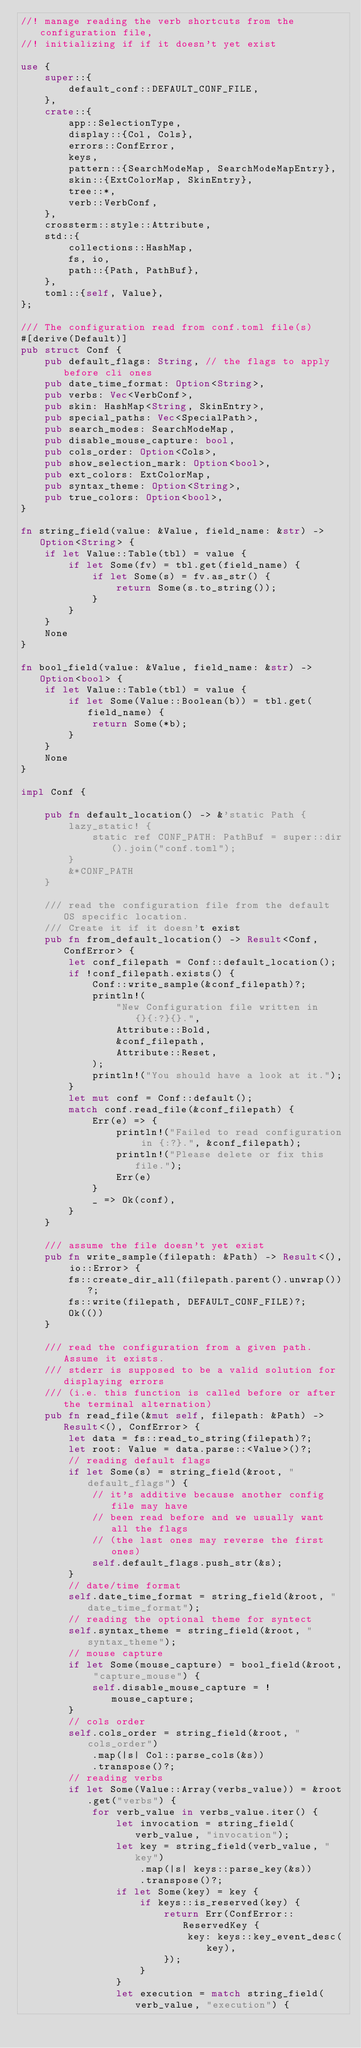Convert code to text. <code><loc_0><loc_0><loc_500><loc_500><_Rust_>//! manage reading the verb shortcuts from the configuration file,
//! initializing if if it doesn't yet exist

use {
    super::{
        default_conf::DEFAULT_CONF_FILE,
    },
    crate::{
        app::SelectionType,
        display::{Col, Cols},
        errors::ConfError,
        keys,
        pattern::{SearchModeMap, SearchModeMapEntry},
        skin::{ExtColorMap, SkinEntry},
        tree::*,
        verb::VerbConf,
    },
    crossterm::style::Attribute,
    std::{
        collections::HashMap,
        fs, io,
        path::{Path, PathBuf},
    },
    toml::{self, Value},
};

/// The configuration read from conf.toml file(s)
#[derive(Default)]
pub struct Conf {
    pub default_flags: String, // the flags to apply before cli ones
    pub date_time_format: Option<String>,
    pub verbs: Vec<VerbConf>,
    pub skin: HashMap<String, SkinEntry>,
    pub special_paths: Vec<SpecialPath>,
    pub search_modes: SearchModeMap,
    pub disable_mouse_capture: bool,
    pub cols_order: Option<Cols>,
    pub show_selection_mark: Option<bool>,
    pub ext_colors: ExtColorMap,
    pub syntax_theme: Option<String>,
    pub true_colors: Option<bool>,
}

fn string_field(value: &Value, field_name: &str) -> Option<String> {
    if let Value::Table(tbl) = value {
        if let Some(fv) = tbl.get(field_name) {
            if let Some(s) = fv.as_str() {
                return Some(s.to_string());
            }
        }
    }
    None
}

fn bool_field(value: &Value, field_name: &str) -> Option<bool> {
    if let Value::Table(tbl) = value {
        if let Some(Value::Boolean(b)) = tbl.get(field_name) {
            return Some(*b);
        }
    }
    None
}

impl Conf {

    pub fn default_location() -> &'static Path {
        lazy_static! {
            static ref CONF_PATH: PathBuf = super::dir().join("conf.toml");
        }
        &*CONF_PATH
    }

    /// read the configuration file from the default OS specific location.
    /// Create it if it doesn't exist
    pub fn from_default_location() -> Result<Conf, ConfError> {
        let conf_filepath = Conf::default_location();
        if !conf_filepath.exists() {
            Conf::write_sample(&conf_filepath)?;
            println!(
                "New Configuration file written in {}{:?}{}.",
                Attribute::Bold,
                &conf_filepath,
                Attribute::Reset,
            );
            println!("You should have a look at it.");
        }
        let mut conf = Conf::default();
        match conf.read_file(&conf_filepath) {
            Err(e) => {
                println!("Failed to read configuration in {:?}.", &conf_filepath);
                println!("Please delete or fix this file.");
                Err(e)
            }
            _ => Ok(conf),
        }
    }

    /// assume the file doesn't yet exist
    pub fn write_sample(filepath: &Path) -> Result<(), io::Error> {
        fs::create_dir_all(filepath.parent().unwrap())?;
        fs::write(filepath, DEFAULT_CONF_FILE)?;
        Ok(())
    }

    /// read the configuration from a given path. Assume it exists.
    /// stderr is supposed to be a valid solution for displaying errors
    /// (i.e. this function is called before or after the terminal alternation)
    pub fn read_file(&mut self, filepath: &Path) -> Result<(), ConfError> {
        let data = fs::read_to_string(filepath)?;
        let root: Value = data.parse::<Value>()?;
        // reading default flags
        if let Some(s) = string_field(&root, "default_flags") {
            // it's additive because another config file may have
            // been read before and we usually want all the flags
            // (the last ones may reverse the first ones)
            self.default_flags.push_str(&s);
        }
        // date/time format
        self.date_time_format = string_field(&root, "date_time_format");
        // reading the optional theme for syntect
        self.syntax_theme = string_field(&root, "syntax_theme");
        // mouse capture
        if let Some(mouse_capture) = bool_field(&root, "capture_mouse") {
            self.disable_mouse_capture = !mouse_capture;
        }
        // cols order
        self.cols_order = string_field(&root, "cols_order")
            .map(|s| Col::parse_cols(&s))
            .transpose()?;
        // reading verbs
        if let Some(Value::Array(verbs_value)) = &root.get("verbs") {
            for verb_value in verbs_value.iter() {
                let invocation = string_field(verb_value, "invocation");
                let key = string_field(verb_value, "key")
                    .map(|s| keys::parse_key(&s))
                    .transpose()?;
                if let Some(key) = key {
                    if keys::is_reserved(key) {
                        return Err(ConfError::ReservedKey {
                            key: keys::key_event_desc(key),
                        });
                    }
                }
                let execution = match string_field(verb_value, "execution") {</code> 